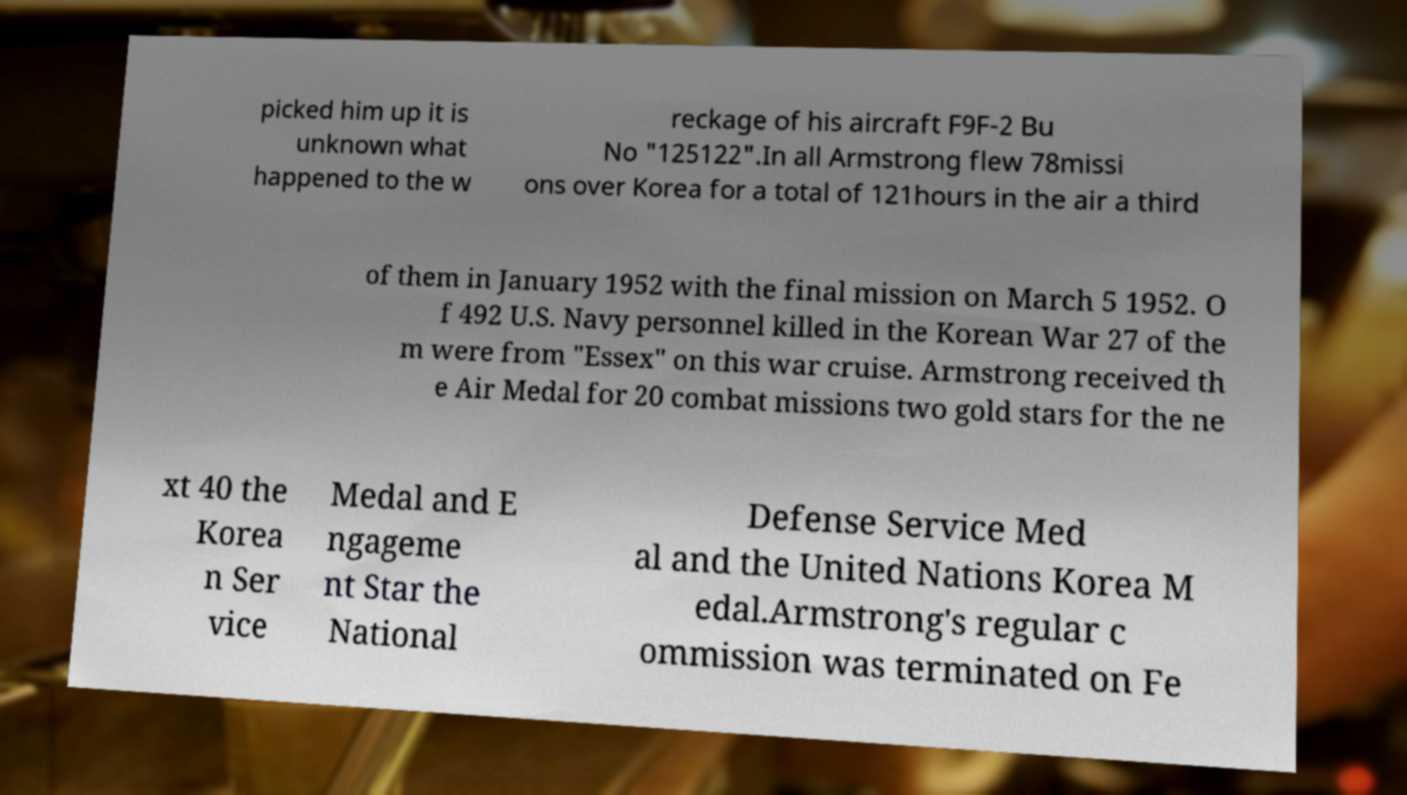Could you assist in decoding the text presented in this image and type it out clearly? picked him up it is unknown what happened to the w reckage of his aircraft F9F-2 Bu No "125122".In all Armstrong flew 78missi ons over Korea for a total of 121hours in the air a third of them in January 1952 with the final mission on March 5 1952. O f 492 U.S. Navy personnel killed in the Korean War 27 of the m were from "Essex" on this war cruise. Armstrong received th e Air Medal for 20 combat missions two gold stars for the ne xt 40 the Korea n Ser vice Medal and E ngageme nt Star the National Defense Service Med al and the United Nations Korea M edal.Armstrong's regular c ommission was terminated on Fe 